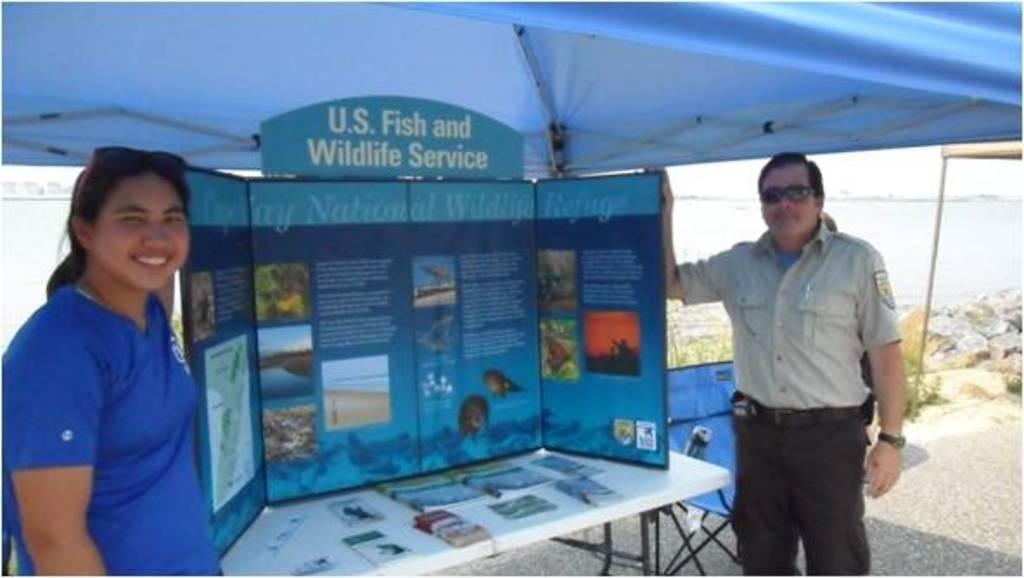In one or two sentences, can you explain what this image depicts? In this picture I can see a man and woman holding the board. I can see the table. I can see the tent. I can see water in the background. 